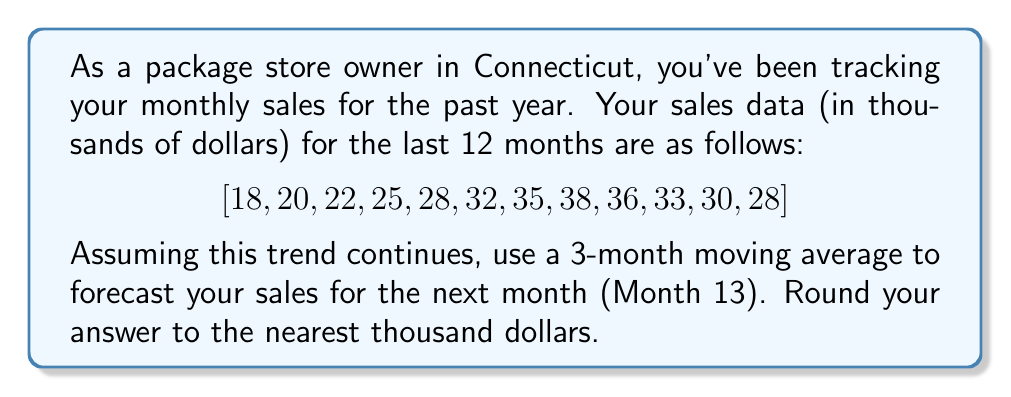Give your solution to this math problem. To solve this problem, we'll use a 3-month moving average method to forecast the next month's sales. Here's the step-by-step process:

1) First, let's calculate the 3-month moving averages for the given data:

   $$\begin{align}
   \text{Months 1-3:} & \frac{18 + 20 + 22}{3} = 20 \\
   \text{Months 2-4:} & \frac{20 + 22 + 25}{3} = 22.33 \\
   \text{Months 3-5:} & \frac{22 + 25 + 28}{3} = 25 \\
   \text{Months 4-6:} & \frac{25 + 28 + 32}{3} = 28.33 \\
   \text{Months 5-7:} & \frac{28 + 32 + 35}{3} = 31.67 \\
   \text{Months 6-8:} & \frac{32 + 35 + 38}{3} = 35 \\
   \text{Months 7-9:} & \frac{35 + 38 + 36}{3} = 36.33 \\
   \text{Months 8-10:} & \frac{38 + 36 + 33}{3} = 35.67 \\
   \text{Months 9-11:} & \frac{36 + 33 + 30}{3} = 33 \\
   \text{Months 10-12:} & \frac{33 + 30 + 28}{3} = 30.33
   \end{align}$$

2) To forecast the next month (Month 13), we'll use the last 3-month average:

   $$\text{Months 11-13:} \frac{30 + 28 + x}{3} = 30.33$$

   Where $x$ is the forecasted sales for Month 13.

3) Solve for $x$:

   $$\begin{align}
   \frac{30 + 28 + x}{3} &= 30.33 \\
   30 + 28 + x &= 30.33 \times 3 \\
   30 + 28 + x &= 91 \\
   x &= 91 - 30 - 28 \\
   x &= 33
   \end{align}$$

4) Therefore, the forecasted sales for Month 13 is $33,000.

Rounding to the nearest thousand dollars, our final answer is $33,000.
Answer: $33,000 